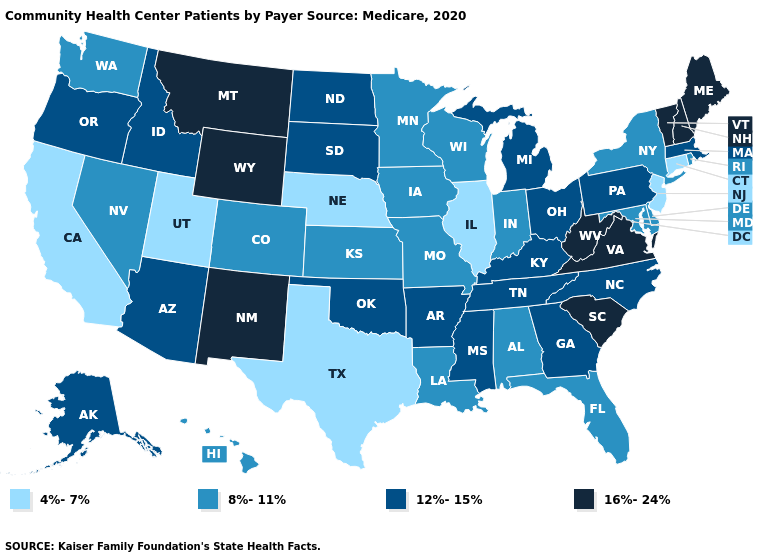Among the states that border South Carolina , which have the highest value?
Give a very brief answer. Georgia, North Carolina. Name the states that have a value in the range 12%-15%?
Keep it brief. Alaska, Arizona, Arkansas, Georgia, Idaho, Kentucky, Massachusetts, Michigan, Mississippi, North Carolina, North Dakota, Ohio, Oklahoma, Oregon, Pennsylvania, South Dakota, Tennessee. Among the states that border New York , which have the lowest value?
Write a very short answer. Connecticut, New Jersey. Does the first symbol in the legend represent the smallest category?
Keep it brief. Yes. Does Texas have the lowest value in the South?
Concise answer only. Yes. Does the first symbol in the legend represent the smallest category?
Concise answer only. Yes. Does New Mexico have the highest value in the USA?
Quick response, please. Yes. Does Illinois have a lower value than Maine?
Answer briefly. Yes. Among the states that border Texas , which have the highest value?
Be succinct. New Mexico. What is the value of Illinois?
Quick response, please. 4%-7%. What is the value of Pennsylvania?
Write a very short answer. 12%-15%. Among the states that border Connecticut , does Massachusetts have the lowest value?
Quick response, please. No. Name the states that have a value in the range 16%-24%?
Answer briefly. Maine, Montana, New Hampshire, New Mexico, South Carolina, Vermont, Virginia, West Virginia, Wyoming. What is the value of Maine?
Give a very brief answer. 16%-24%. 